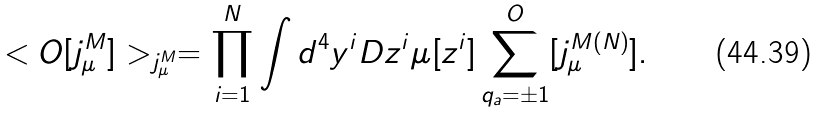<formula> <loc_0><loc_0><loc_500><loc_500>< O [ j _ { \mu } ^ { M } ] > _ { j _ { \mu } ^ { M } } = \prod _ { i = 1 } ^ { N } \int d ^ { 4 } y ^ { i } D z ^ { i } \mu [ z ^ { i } ] \sum _ { q _ { a } = \pm 1 } ^ { O } [ j _ { \mu } ^ { M ( N ) } ] .</formula> 